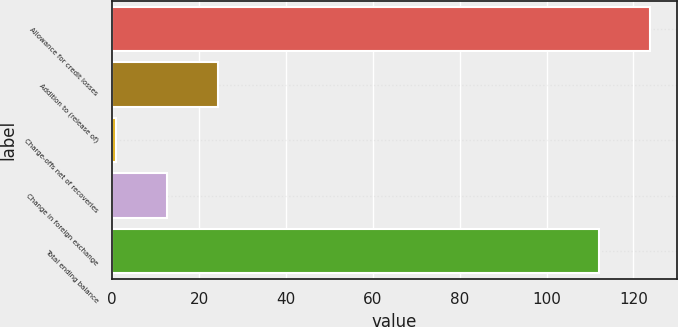<chart> <loc_0><loc_0><loc_500><loc_500><bar_chart><fcel>Allowance for credit losses<fcel>Addition to (release of)<fcel>Charge-offs net of recoveries<fcel>Change in foreign exchange<fcel>Total ending balance<nl><fcel>123.82<fcel>24.43<fcel>0.79<fcel>12.61<fcel>112<nl></chart> 